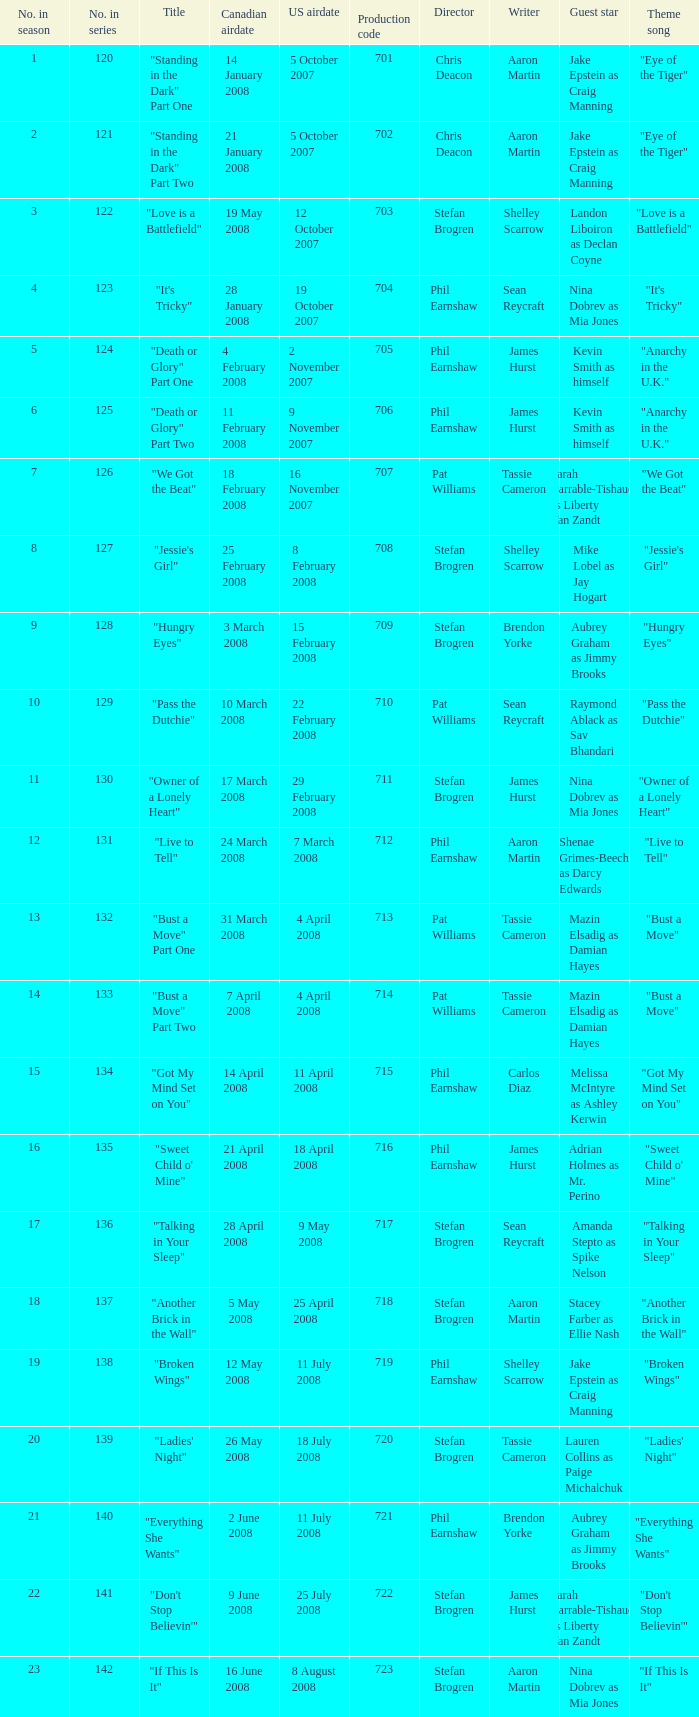The canadian airdate of 17 march 2008 had how many numbers in the season? 1.0. 